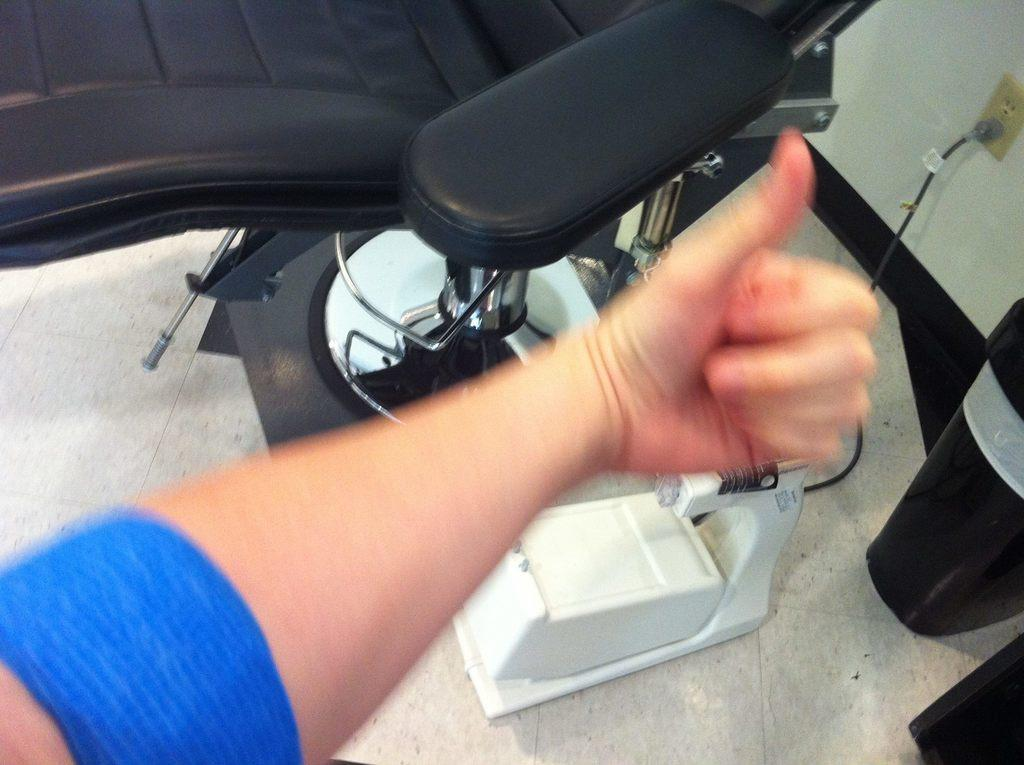What part of a person can be seen in the image? There is a hand of a person in the image. What type of furniture is present in the image? There is a black chair in the image. What is on the right side of the image? There is a wall on the right side of the image. What is attached to the wall in the image? There is a switchboard on the wall. What type of apple is being used as a light switch in the image? There is no apple present in the image, and therefore it cannot be used as a light switch. 